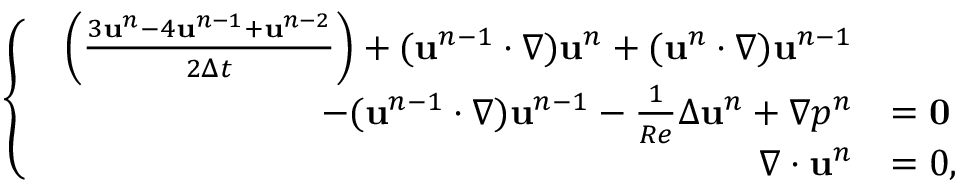<formula> <loc_0><loc_0><loc_500><loc_500>\begin{array} { r } { \left \{ \begin{array} { l l } { \begin{array} { r l } { \left ( \frac { 3 u ^ { n } - 4 u ^ { n - 1 } + u ^ { n - 2 } } { 2 \Delta t } \right ) + ( u ^ { n - 1 } \cdot \nabla ) u ^ { n } + ( u ^ { n } \cdot \nabla ) u ^ { n - 1 } } \\ { - ( u ^ { n - 1 } \cdot \nabla ) u ^ { n - 1 } - \frac { 1 } { R e } \Delta u ^ { n } + \nabla p ^ { n } } & { = 0 } \\ { \nabla \cdot u ^ { n } } & { = 0 , } \end{array} } \end{array} } \end{array}</formula> 